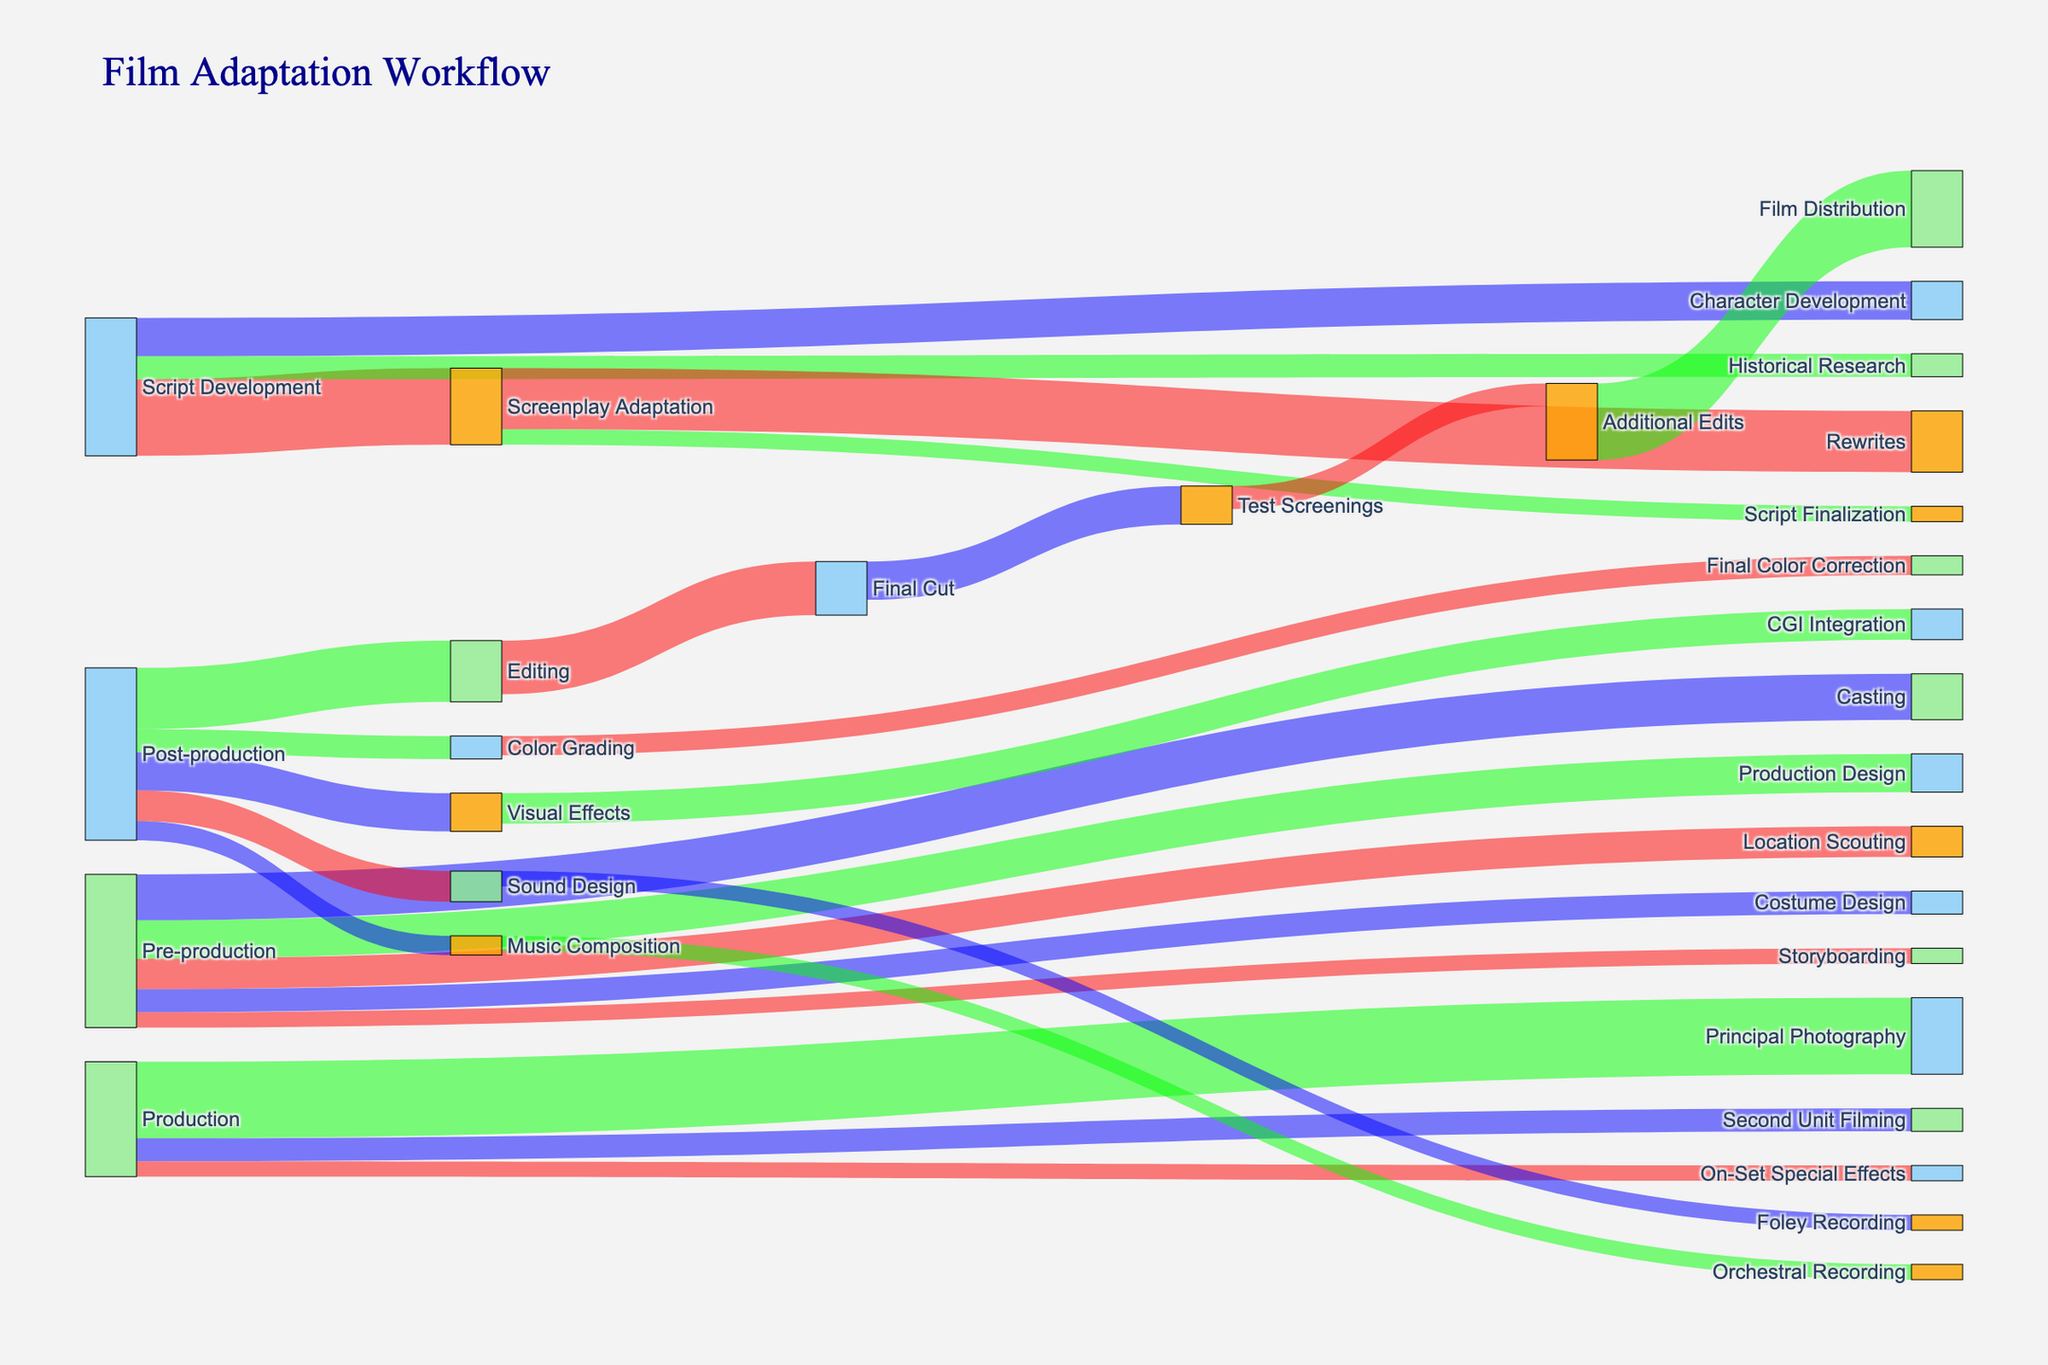What is the title of the Sankey diagram? The title is displayed at the top of the diagram. It provides a brief description or name of the figure.
Answer: Film Adaptation Workflow What is the total value of resources allocated to Script Development? Combine the values of all resources flowing out from Script Development; 100 (Screenplay Adaptation) + 30 (Historical Research) + 50 (Character Development) = 180.
Answer: 180 Which stage has the highest single resource allocation value during Pre-production? Examine the values flowing out from Pre-production. The highest value is for Casting, which is 60.
Answer: Casting How much more resource is allocated to Principal Photography compared to Second Unit Filming in Production? Subtract the value of Second Unit Filming from the value of Principal Photography; 100 (Principal Photography) - 30 (Second Unit Filming) = 70.
Answer: 70 What stages are involved after Editing in Post-production? Trace the flow from Editing to find the subsequent stages. Editing flows to Final Cut, which then flows to Test Screenings and Additional Edits.
Answer: Final Cut, Test Screenings, Additional Edits Compare the resources allocated to Sound Design and Visual Effects in Post-production. Which receives more, and by how much? Check the values for Sound Design and Visual Effects. Visual Effects has 50, and Sound Design has 40. The difference is 50 - 40 = 10.
Answer: Visual Effects, 10 Which stage is immediately before Film Distribution? Locate Film Distribution in the diagram and trace the flow backward to find the previous stage. It is Additional Edits.
Answer: Additional Edits What is the total resource allocated to Post-production stages collectively? Sum all the values flowing out of Post-production; 80 (Editing) + 50 (Visual Effects) + 40 (Sound Design) + 30 (Color Grading) + 25 (Music Composition) = 225.
Answer: 225 What is the combined value of resources allocated to Rewrites and Script Finalization? Add the values of Rewrites and Script Finalization together; 80 (Rewrites) + 20 (Script Finalization) = 100.
Answer: 100 Is resource allocation higher for Historical Research or Character Development during Script Development? Compare the values flowing out from Script Development to Historical Research and Character Development. Historical Research has 30 and Character Development has 50.
Answer: Character Development 